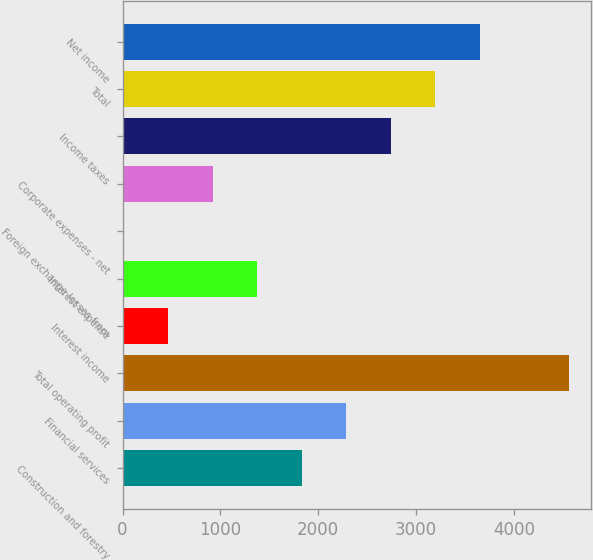<chart> <loc_0><loc_0><loc_500><loc_500><bar_chart><fcel>Construction and forestry<fcel>Financial services<fcel>Total operating profit<fcel>Interest income<fcel>Interest expense<fcel>Foreign exchange losses from<fcel>Corporate expenses - net<fcel>Income taxes<fcel>Total<fcel>Net income<nl><fcel>1832.2<fcel>2287.5<fcel>4564<fcel>466.3<fcel>1376.9<fcel>11<fcel>921.6<fcel>2742.8<fcel>3198.1<fcel>3653.4<nl></chart> 